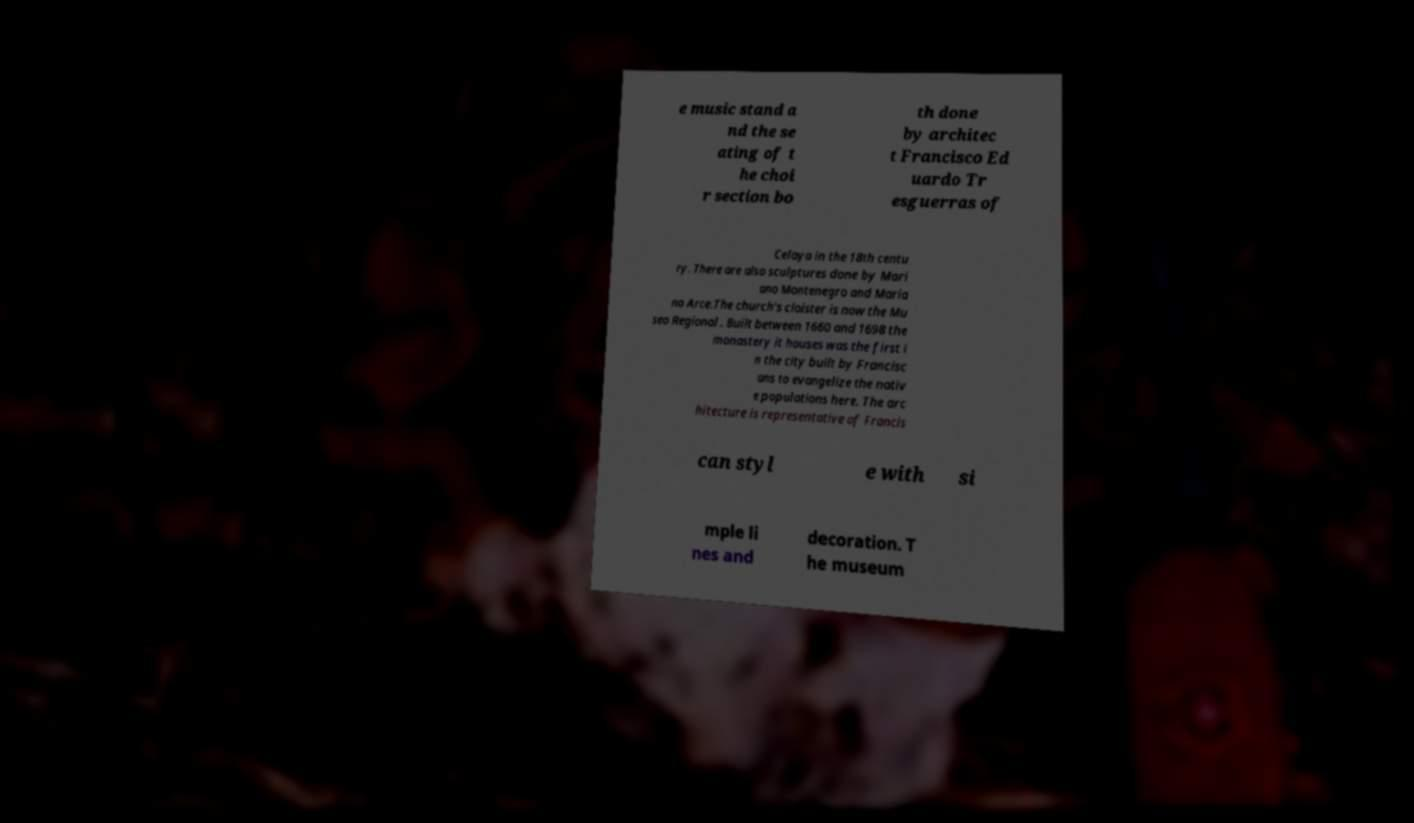There's text embedded in this image that I need extracted. Can you transcribe it verbatim? e music stand a nd the se ating of t he choi r section bo th done by architec t Francisco Ed uardo Tr esguerras of Celaya in the 18th centu ry. There are also sculptures done by Mari ano Montenegro and Maria no Arce.The church's cloister is now the Mu seo Regional . Built between 1660 and 1698 the monastery it houses was the first i n the city built by Francisc ans to evangelize the nativ e populations here. The arc hitecture is representative of Francis can styl e with si mple li nes and decoration. T he museum 